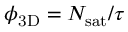<formula> <loc_0><loc_0><loc_500><loc_500>{ \phi _ { 3 D } } = { N _ { s a t } } / \tau</formula> 